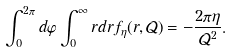Convert formula to latex. <formula><loc_0><loc_0><loc_500><loc_500>\int _ { 0 } ^ { 2 \pi } d \varphi \int _ { 0 } ^ { \infty } r d r f _ { \eta } ( r , \mathcal { Q } ) = - \frac { 2 \pi \eta } { \mathcal { Q } ^ { 2 } } .</formula> 